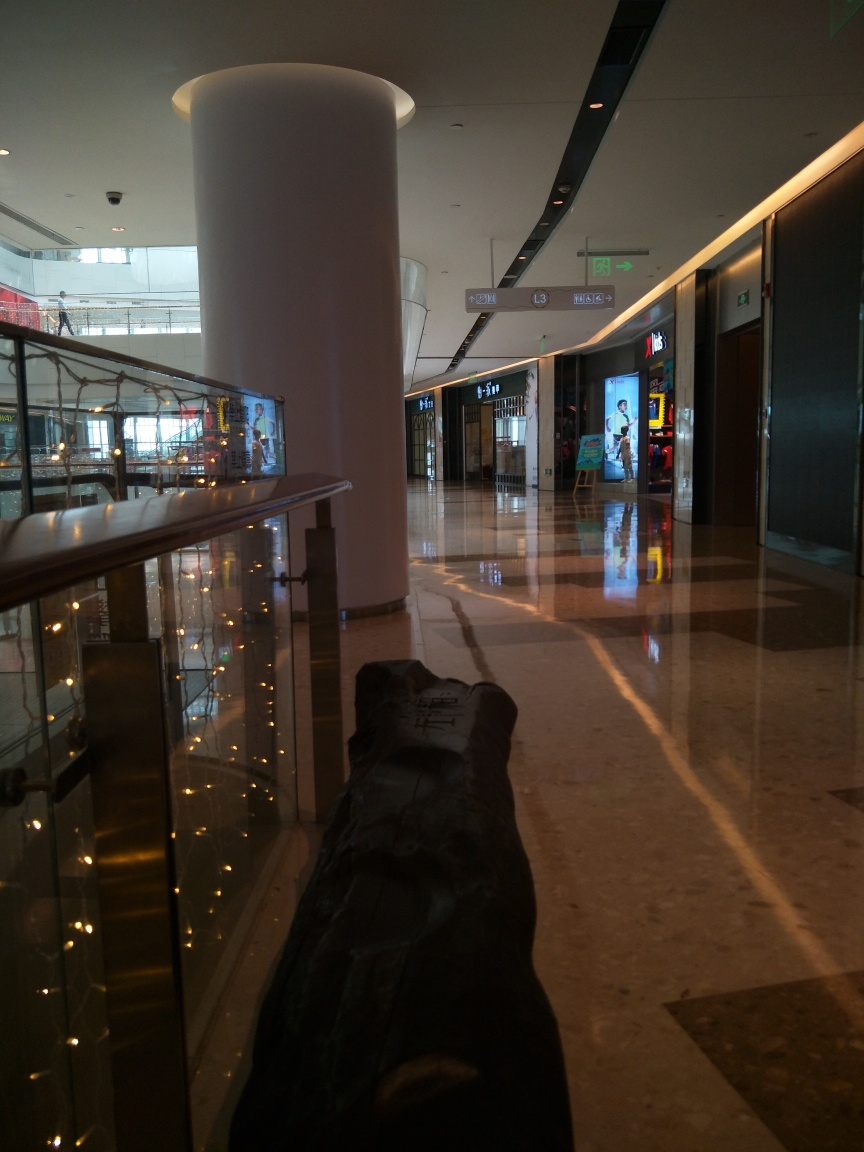Is this location busy right now? The location does not seem particularly busy. There are a few visible individuals in the distance, but the area appears calm with no signs of a crowd. 